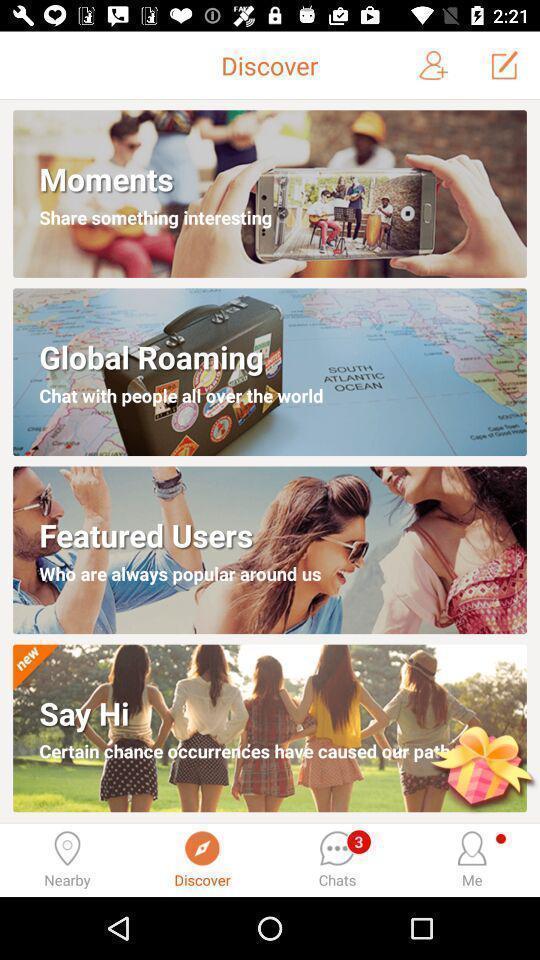Provide a textual representation of this image. Page showing discover option to find someone to chat. 